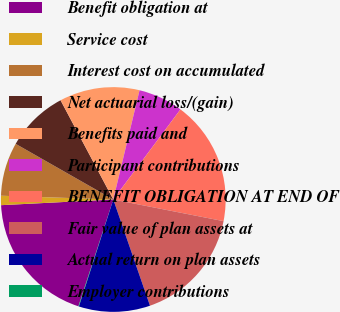<chart> <loc_0><loc_0><loc_500><loc_500><pie_chart><fcel>Benefit obligation at<fcel>Service cost<fcel>Interest cost on accumulated<fcel>Net actuarial loss/(gain)<fcel>Benefits paid and<fcel>Participant contributions<fcel>BENEFIT OBLIGATION AT END OF<fcel>Fair value of plan assets at<fcel>Actual return on plan assets<fcel>Employer contributions<nl><fcel>19.17%<fcel>1.34%<fcel>7.71%<fcel>8.98%<fcel>11.53%<fcel>6.44%<fcel>17.89%<fcel>16.62%<fcel>10.25%<fcel>0.07%<nl></chart> 